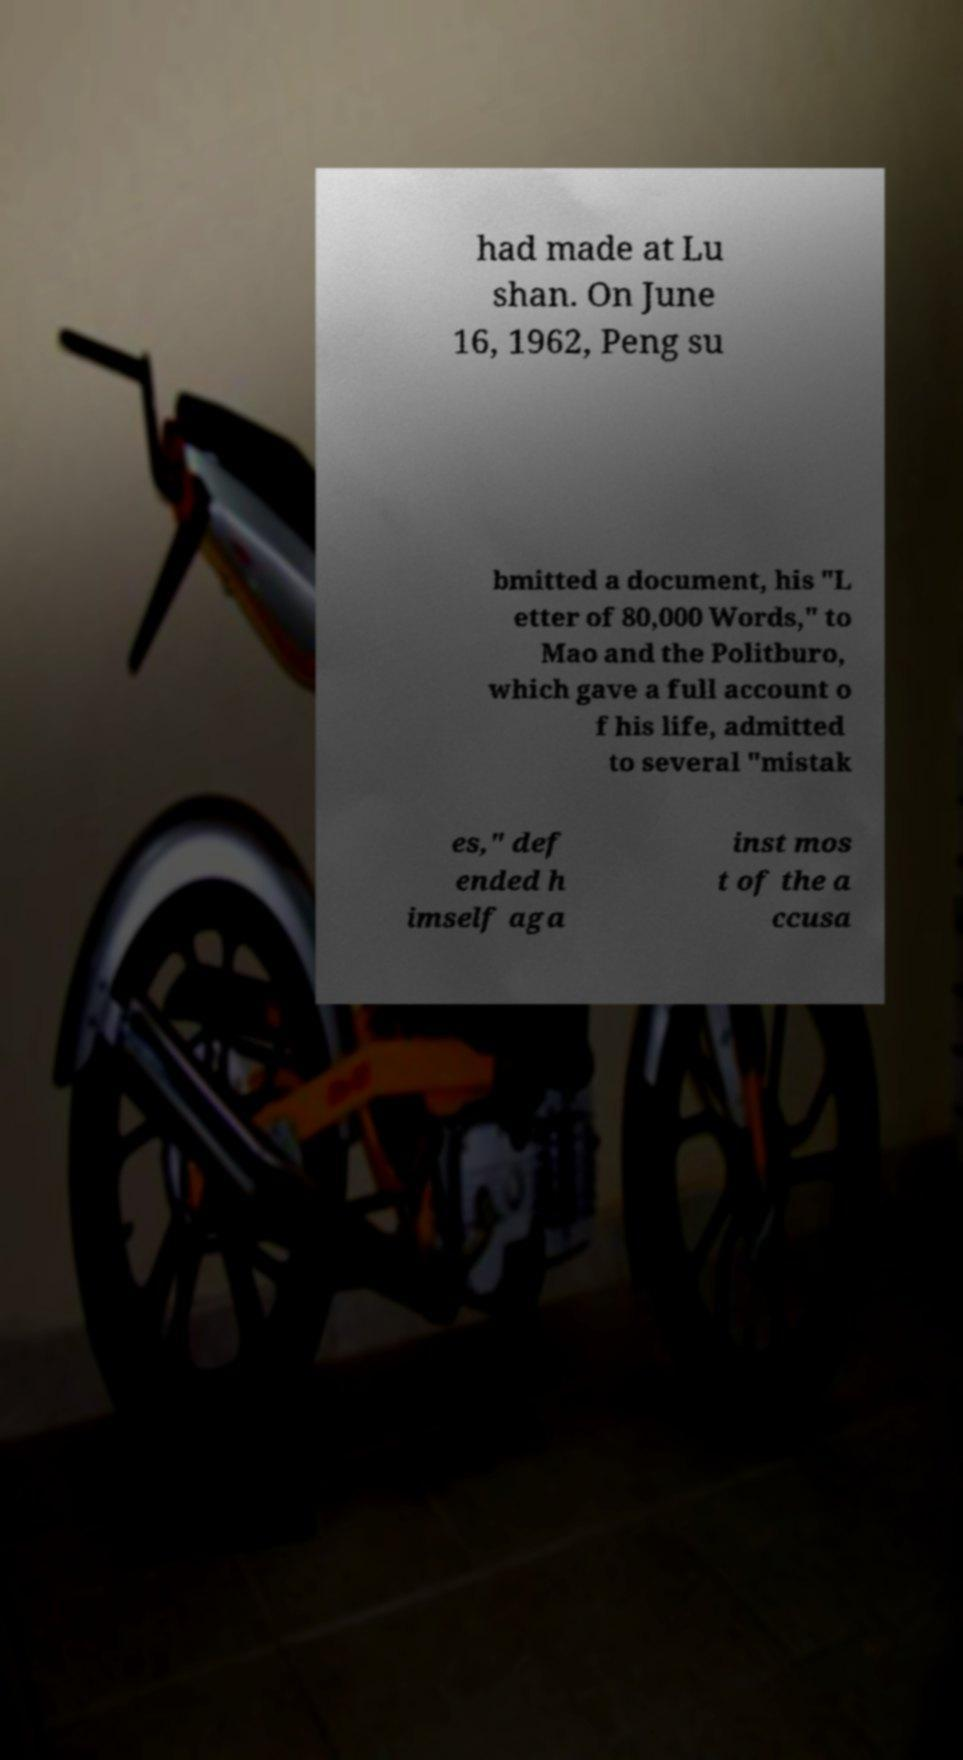For documentation purposes, I need the text within this image transcribed. Could you provide that? had made at Lu shan. On June 16, 1962, Peng su bmitted a document, his "L etter of 80,000 Words," to Mao and the Politburo, which gave a full account o f his life, admitted to several "mistak es," def ended h imself aga inst mos t of the a ccusa 